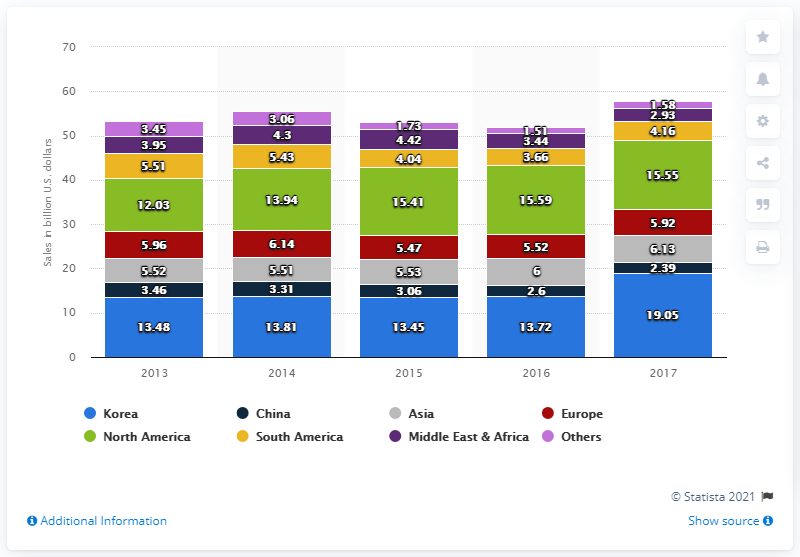Indicate a few pertinent items in this graphic. In 2014, LG Electronics' sales in Korea accounted for 13.81% of its total sales revenue. The sales revenue of LG Electronics in North America in 2017 was 15.55... The maximum sales in Korea over the years is significantly higher than the minimum sales in Asia over the same period. 